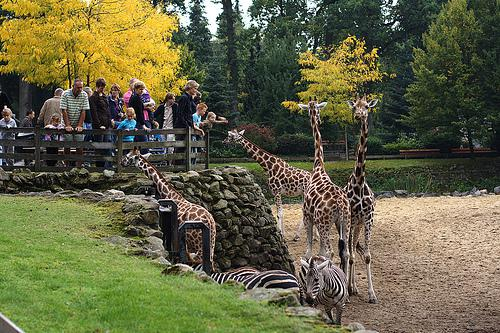Question: what animal is seen?
Choices:
A. Giraffe and zebra.
B. A goat.
C. A brown bear.
D. A cat and dog.
Answer with the letter. Answer: A Question: what is the color of the spots?
Choices:
A. Brown.
B. Yellow.
C. Blue.
D. Red.
Answer with the letter. Answer: A Question: how many giraffe are there?
Choices:
A. 5.
B. 6.
C. 7.
D. 4.
Answer with the letter. Answer: D Question: what is the color of the zebra?
Choices:
A. Black and white.
B. Yellow and Brown.
C. Black and Gold.
D. Blue and Green.
Answer with the letter. Answer: A Question: what is the color of the grass?
Choices:
A. Green.
B. Black.
C. Blue.
D. Pink.
Answer with the letter. Answer: A Question: what is the color of the fence?
Choices:
A. Yellow.
B. Blue.
C. Pink.
D. Grey.
Answer with the letter. Answer: D Question: where is the picture taken?
Choices:
A. In front of a statue.
B. In a zoo.
C. At the museum.
D. On a ferry.
Answer with the letter. Answer: B 